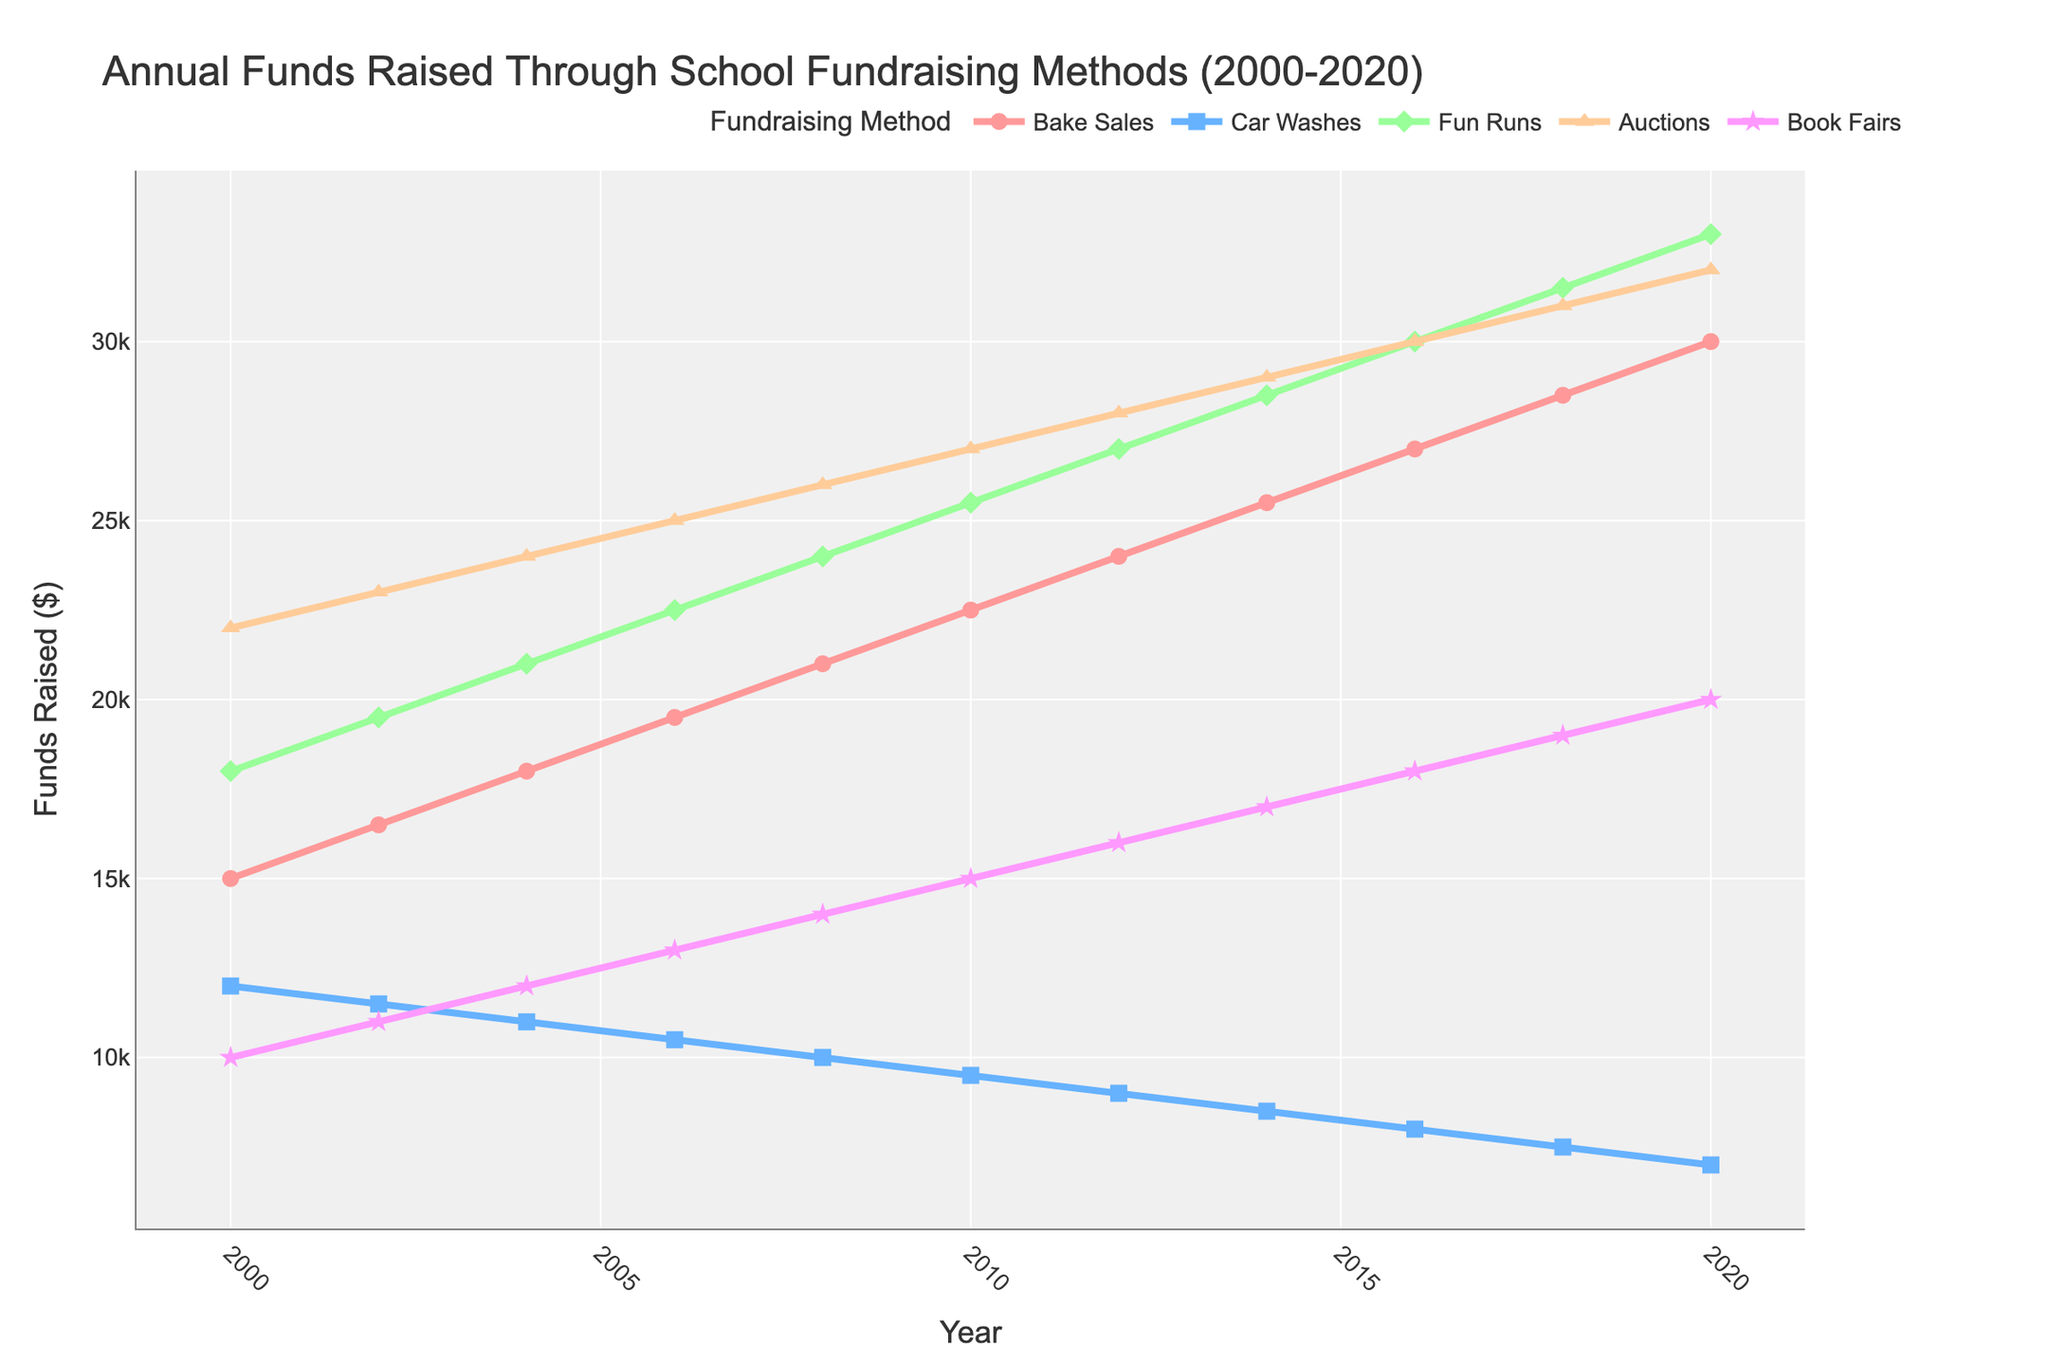what's the total amount of funds raised through bake sales and car washes in 2010? To find the total amount of funds raised through bake sales and car washes in 2010, add the amount from bake sales ($22,500) and the amount from car washes ($9,500). The total is 22,500 + 9,500 = $32,000.
Answer: $32,000 which fundraising method raised the most funds in 2020? Observe the lines corresponding to each fundraising method in 2020 and compare their values. Auctions raised the most funds with $32,000.
Answer: Auctions how much more funds were raised through fun runs than car washes in 2018? Find the funds raised through fun runs ($31,500) and through car washes ($7,500) in 2018. Subtract the two: 31,500 - 7,500 = $24,000.
Answer: $24,000 what is the trend in funds raised through bake sales from 2000 to 2020? Observe the line representing bake sales from 2000 to 2020. The funds raised through bake sales show a steady increasing trend over the years, rising from $15,000 in 2000 to $30,000 in 2020.
Answer: Steadily increasing which two fundraising methods had the least funds raised in 2004? Compare the values for each fundraising method in 2004. The least funds raised were through car washes ($11,000) and book fairs ($12,000).
Answer: Car washes and book fairs what was the difference in funds raised between auctions and bake sales in 2016? In 2016, auctions raised $30,000 and bake sales raised $27,000. The difference is 30,000 - 27,000 = $3,000.
Answer: $3,000 which fundraising method experienced the most consistent increase in funds raised from 2000 to 2020? Examine the lines corresponding to each fundraising method. Bake sales exhibit the most consistent and steady increase in funds raised from 2000 ($15,000) to 2020 ($30,000).
Answer: Bake sales what was the average amount of funds raised annually through book fairs from 2000 to 2020? Sum the funds raised through book fairs for each year and divide by the number of years (11). The total is 10,000 + 11,000 + 12,000 + 13,000 + 14,000 + 15,000 + 16,000 + 17,000 + 18,000 + 19,000 + 20,000 = 165,000. The average is 165,000 / 11 = $15,000.
Answer: $15,000 